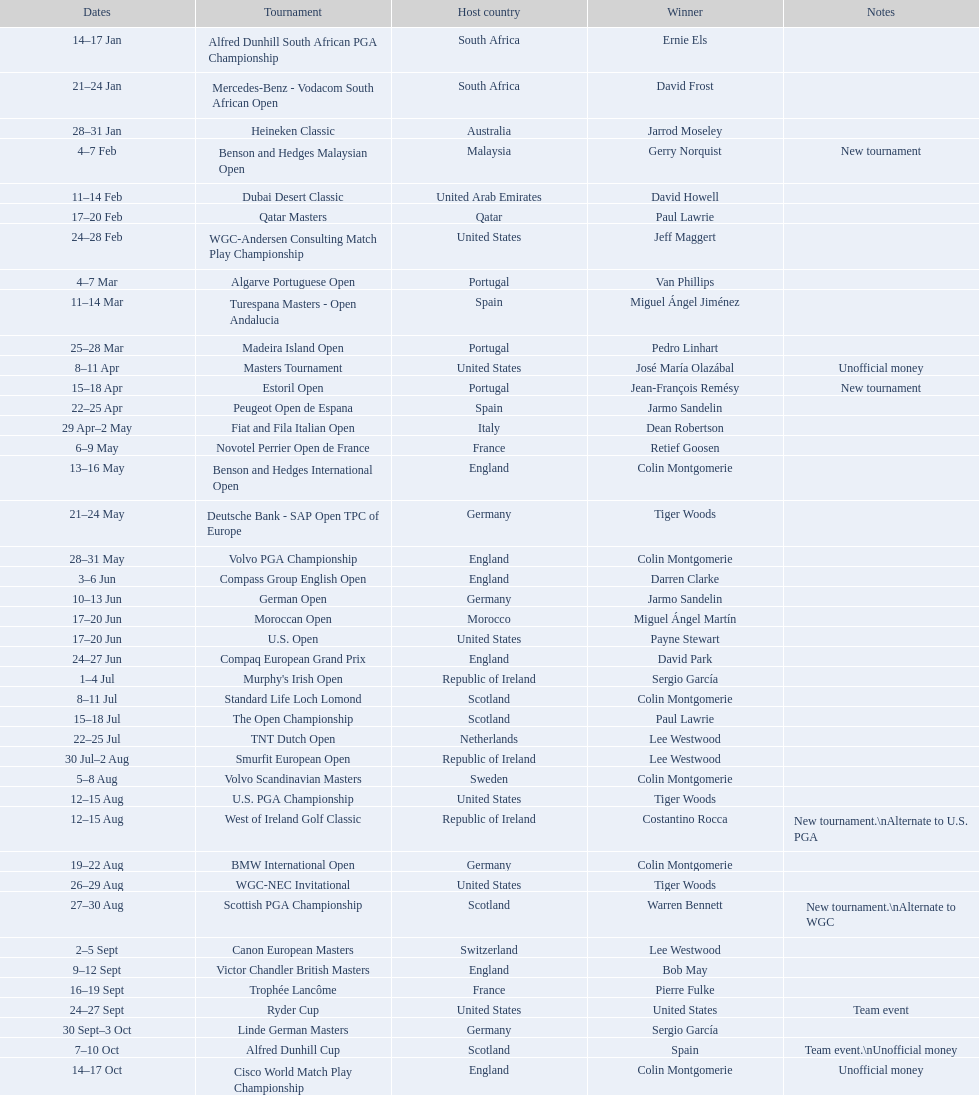What was the length of the estoril open event? 3 days. 